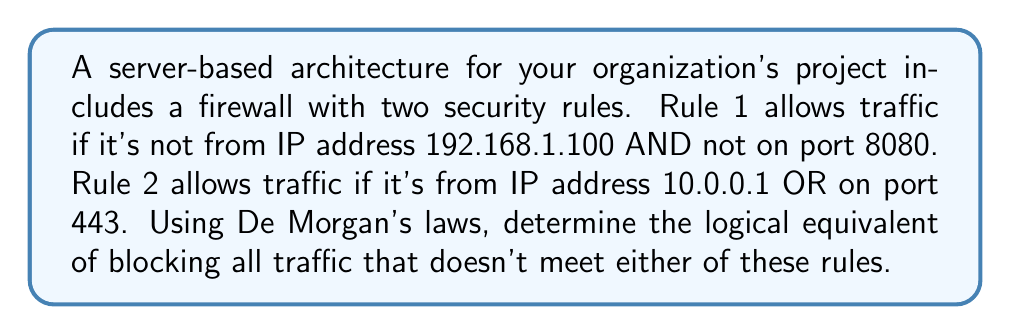Solve this math problem. Let's approach this step-by-step:

1) First, let's define our variables:
   $A$: Traffic is from IP 192.168.1.100
   $B$: Traffic is on port 8080
   $C$: Traffic is from IP 10.0.0.1
   $D$: Traffic is on port 443

2) Rule 1 can be expressed as: $\neg A \land \neg B$
   Rule 2 can be expressed as: $C \lor D$

3) The condition for allowing traffic is: $(\neg A \land \neg B) \lor (C \lor D)$

4) We want to block traffic that doesn't meet either rule, so we need to negate this expression:
   $\neg((\neg A \land \neg B) \lor (C \lor D))$

5) Applying De Morgan's law to the outer negation:
   $((\neg(\neg A \land \neg B)) \land (\neg(C \lor D)))$

6) Applying De Morgan's law to $\neg(\neg A \land \neg B)$:
   $((A \lor B) \land (\neg(C \lor D)))$

7) Applying De Morgan's law to $\neg(C \lor D)$:
   $((A \lor B) \land (\neg C \land \neg D))$

8) This final expression represents the condition for blocking traffic.
Answer: $(A \lor B) \land (\neg C \land \neg D)$ 